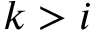<formula> <loc_0><loc_0><loc_500><loc_500>k > i</formula> 